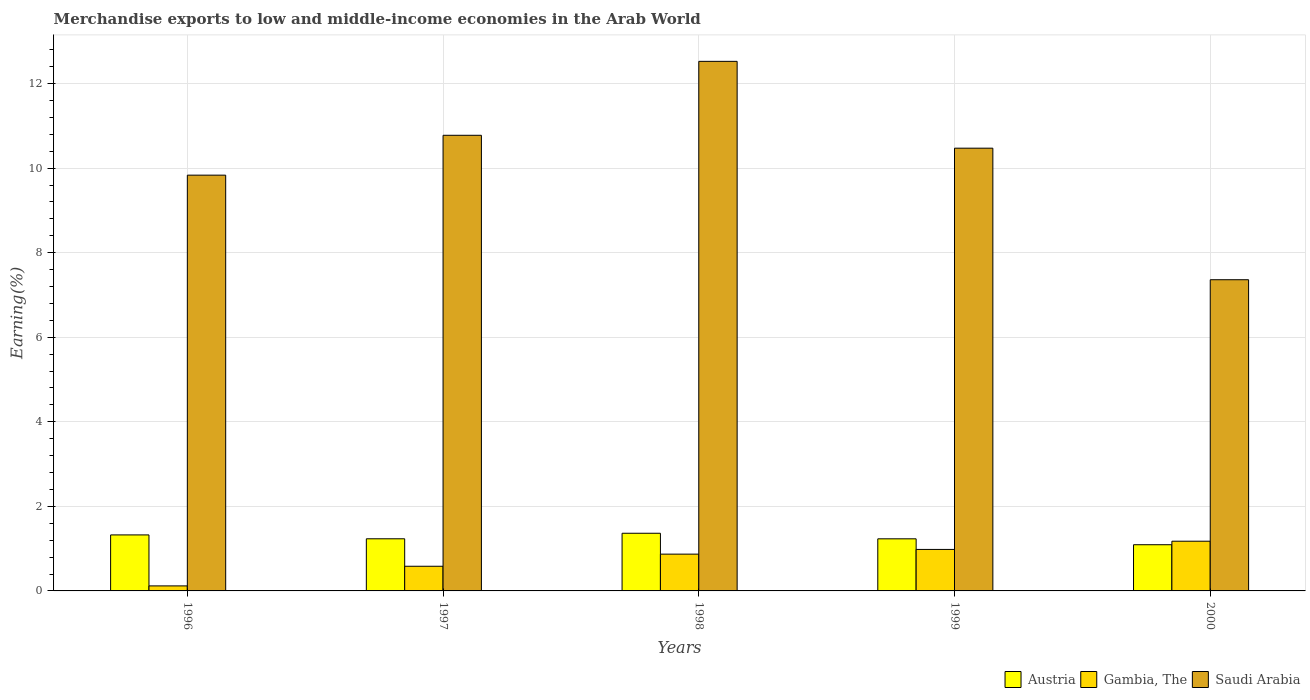How many different coloured bars are there?
Offer a terse response. 3. Are the number of bars on each tick of the X-axis equal?
Your answer should be compact. Yes. How many bars are there on the 5th tick from the right?
Your answer should be compact. 3. What is the label of the 4th group of bars from the left?
Make the answer very short. 1999. In how many cases, is the number of bars for a given year not equal to the number of legend labels?
Make the answer very short. 0. What is the percentage of amount earned from merchandise exports in Saudi Arabia in 1997?
Your response must be concise. 10.78. Across all years, what is the maximum percentage of amount earned from merchandise exports in Austria?
Your answer should be compact. 1.36. Across all years, what is the minimum percentage of amount earned from merchandise exports in Gambia, The?
Your answer should be compact. 0.12. What is the total percentage of amount earned from merchandise exports in Austria in the graph?
Your answer should be very brief. 6.25. What is the difference between the percentage of amount earned from merchandise exports in Austria in 1997 and that in 1998?
Make the answer very short. -0.13. What is the difference between the percentage of amount earned from merchandise exports in Gambia, The in 1997 and the percentage of amount earned from merchandise exports in Austria in 1996?
Provide a succinct answer. -0.74. What is the average percentage of amount earned from merchandise exports in Austria per year?
Keep it short and to the point. 1.25. In the year 2000, what is the difference between the percentage of amount earned from merchandise exports in Gambia, The and percentage of amount earned from merchandise exports in Saudi Arabia?
Your answer should be very brief. -6.18. In how many years, is the percentage of amount earned from merchandise exports in Austria greater than 9.2 %?
Keep it short and to the point. 0. What is the ratio of the percentage of amount earned from merchandise exports in Gambia, The in 1996 to that in 1999?
Your answer should be very brief. 0.12. Is the percentage of amount earned from merchandise exports in Austria in 1997 less than that in 2000?
Make the answer very short. No. Is the difference between the percentage of amount earned from merchandise exports in Gambia, The in 1996 and 1999 greater than the difference between the percentage of amount earned from merchandise exports in Saudi Arabia in 1996 and 1999?
Keep it short and to the point. No. What is the difference between the highest and the second highest percentage of amount earned from merchandise exports in Saudi Arabia?
Offer a terse response. 1.75. What is the difference between the highest and the lowest percentage of amount earned from merchandise exports in Gambia, The?
Make the answer very short. 1.06. What does the 3rd bar from the left in 1997 represents?
Offer a very short reply. Saudi Arabia. What does the 2nd bar from the right in 1996 represents?
Ensure brevity in your answer.  Gambia, The. Are all the bars in the graph horizontal?
Give a very brief answer. No. How many years are there in the graph?
Provide a succinct answer. 5. What is the difference between two consecutive major ticks on the Y-axis?
Ensure brevity in your answer.  2. Are the values on the major ticks of Y-axis written in scientific E-notation?
Your answer should be compact. No. Does the graph contain any zero values?
Your answer should be very brief. No. Does the graph contain grids?
Offer a very short reply. Yes. How many legend labels are there?
Your response must be concise. 3. How are the legend labels stacked?
Offer a very short reply. Horizontal. What is the title of the graph?
Ensure brevity in your answer.  Merchandise exports to low and middle-income economies in the Arab World. What is the label or title of the X-axis?
Your answer should be very brief. Years. What is the label or title of the Y-axis?
Provide a succinct answer. Earning(%). What is the Earning(%) in Austria in 1996?
Offer a terse response. 1.32. What is the Earning(%) of Gambia, The in 1996?
Provide a short and direct response. 0.12. What is the Earning(%) in Saudi Arabia in 1996?
Your answer should be compact. 9.83. What is the Earning(%) of Austria in 1997?
Ensure brevity in your answer.  1.23. What is the Earning(%) of Gambia, The in 1997?
Offer a very short reply. 0.58. What is the Earning(%) of Saudi Arabia in 1997?
Offer a terse response. 10.78. What is the Earning(%) of Austria in 1998?
Ensure brevity in your answer.  1.36. What is the Earning(%) in Gambia, The in 1998?
Make the answer very short. 0.87. What is the Earning(%) in Saudi Arabia in 1998?
Your response must be concise. 12.53. What is the Earning(%) of Austria in 1999?
Provide a succinct answer. 1.23. What is the Earning(%) of Gambia, The in 1999?
Offer a very short reply. 0.98. What is the Earning(%) in Saudi Arabia in 1999?
Give a very brief answer. 10.47. What is the Earning(%) in Austria in 2000?
Offer a very short reply. 1.09. What is the Earning(%) of Gambia, The in 2000?
Your answer should be very brief. 1.18. What is the Earning(%) of Saudi Arabia in 2000?
Ensure brevity in your answer.  7.36. Across all years, what is the maximum Earning(%) in Austria?
Give a very brief answer. 1.36. Across all years, what is the maximum Earning(%) of Gambia, The?
Make the answer very short. 1.18. Across all years, what is the maximum Earning(%) of Saudi Arabia?
Offer a very short reply. 12.53. Across all years, what is the minimum Earning(%) in Austria?
Provide a succinct answer. 1.09. Across all years, what is the minimum Earning(%) in Gambia, The?
Provide a short and direct response. 0.12. Across all years, what is the minimum Earning(%) in Saudi Arabia?
Make the answer very short. 7.36. What is the total Earning(%) in Austria in the graph?
Provide a short and direct response. 6.25. What is the total Earning(%) of Gambia, The in the graph?
Your answer should be very brief. 3.73. What is the total Earning(%) in Saudi Arabia in the graph?
Make the answer very short. 50.97. What is the difference between the Earning(%) of Austria in 1996 and that in 1997?
Give a very brief answer. 0.09. What is the difference between the Earning(%) of Gambia, The in 1996 and that in 1997?
Offer a very short reply. -0.46. What is the difference between the Earning(%) in Saudi Arabia in 1996 and that in 1997?
Keep it short and to the point. -0.94. What is the difference between the Earning(%) in Austria in 1996 and that in 1998?
Offer a very short reply. -0.04. What is the difference between the Earning(%) of Gambia, The in 1996 and that in 1998?
Keep it short and to the point. -0.75. What is the difference between the Earning(%) of Saudi Arabia in 1996 and that in 1998?
Provide a succinct answer. -2.69. What is the difference between the Earning(%) of Austria in 1996 and that in 1999?
Provide a short and direct response. 0.09. What is the difference between the Earning(%) in Gambia, The in 1996 and that in 1999?
Provide a short and direct response. -0.86. What is the difference between the Earning(%) of Saudi Arabia in 1996 and that in 1999?
Your answer should be very brief. -0.64. What is the difference between the Earning(%) in Austria in 1996 and that in 2000?
Provide a succinct answer. 0.23. What is the difference between the Earning(%) of Gambia, The in 1996 and that in 2000?
Your answer should be very brief. -1.06. What is the difference between the Earning(%) of Saudi Arabia in 1996 and that in 2000?
Keep it short and to the point. 2.47. What is the difference between the Earning(%) in Austria in 1997 and that in 1998?
Your answer should be compact. -0.13. What is the difference between the Earning(%) in Gambia, The in 1997 and that in 1998?
Your response must be concise. -0.29. What is the difference between the Earning(%) of Saudi Arabia in 1997 and that in 1998?
Provide a short and direct response. -1.75. What is the difference between the Earning(%) of Austria in 1997 and that in 1999?
Offer a very short reply. 0. What is the difference between the Earning(%) of Gambia, The in 1997 and that in 1999?
Your answer should be very brief. -0.4. What is the difference between the Earning(%) in Saudi Arabia in 1997 and that in 1999?
Ensure brevity in your answer.  0.3. What is the difference between the Earning(%) in Austria in 1997 and that in 2000?
Your answer should be very brief. 0.14. What is the difference between the Earning(%) in Gambia, The in 1997 and that in 2000?
Offer a terse response. -0.59. What is the difference between the Earning(%) in Saudi Arabia in 1997 and that in 2000?
Provide a short and direct response. 3.42. What is the difference between the Earning(%) in Austria in 1998 and that in 1999?
Your answer should be compact. 0.13. What is the difference between the Earning(%) in Gambia, The in 1998 and that in 1999?
Provide a succinct answer. -0.11. What is the difference between the Earning(%) in Saudi Arabia in 1998 and that in 1999?
Provide a succinct answer. 2.05. What is the difference between the Earning(%) in Austria in 1998 and that in 2000?
Keep it short and to the point. 0.27. What is the difference between the Earning(%) in Gambia, The in 1998 and that in 2000?
Ensure brevity in your answer.  -0.31. What is the difference between the Earning(%) of Saudi Arabia in 1998 and that in 2000?
Your answer should be very brief. 5.17. What is the difference between the Earning(%) of Austria in 1999 and that in 2000?
Your response must be concise. 0.14. What is the difference between the Earning(%) of Gambia, The in 1999 and that in 2000?
Keep it short and to the point. -0.19. What is the difference between the Earning(%) in Saudi Arabia in 1999 and that in 2000?
Your answer should be compact. 3.11. What is the difference between the Earning(%) of Austria in 1996 and the Earning(%) of Gambia, The in 1997?
Your response must be concise. 0.74. What is the difference between the Earning(%) of Austria in 1996 and the Earning(%) of Saudi Arabia in 1997?
Provide a succinct answer. -9.45. What is the difference between the Earning(%) in Gambia, The in 1996 and the Earning(%) in Saudi Arabia in 1997?
Ensure brevity in your answer.  -10.66. What is the difference between the Earning(%) in Austria in 1996 and the Earning(%) in Gambia, The in 1998?
Provide a succinct answer. 0.45. What is the difference between the Earning(%) in Austria in 1996 and the Earning(%) in Saudi Arabia in 1998?
Ensure brevity in your answer.  -11.2. What is the difference between the Earning(%) in Gambia, The in 1996 and the Earning(%) in Saudi Arabia in 1998?
Your answer should be very brief. -12.41. What is the difference between the Earning(%) in Austria in 1996 and the Earning(%) in Gambia, The in 1999?
Offer a terse response. 0.34. What is the difference between the Earning(%) of Austria in 1996 and the Earning(%) of Saudi Arabia in 1999?
Your response must be concise. -9.15. What is the difference between the Earning(%) in Gambia, The in 1996 and the Earning(%) in Saudi Arabia in 1999?
Make the answer very short. -10.35. What is the difference between the Earning(%) in Austria in 1996 and the Earning(%) in Gambia, The in 2000?
Give a very brief answer. 0.15. What is the difference between the Earning(%) in Austria in 1996 and the Earning(%) in Saudi Arabia in 2000?
Provide a short and direct response. -6.04. What is the difference between the Earning(%) of Gambia, The in 1996 and the Earning(%) of Saudi Arabia in 2000?
Your response must be concise. -7.24. What is the difference between the Earning(%) in Austria in 1997 and the Earning(%) in Gambia, The in 1998?
Keep it short and to the point. 0.36. What is the difference between the Earning(%) in Austria in 1997 and the Earning(%) in Saudi Arabia in 1998?
Provide a succinct answer. -11.29. What is the difference between the Earning(%) in Gambia, The in 1997 and the Earning(%) in Saudi Arabia in 1998?
Keep it short and to the point. -11.94. What is the difference between the Earning(%) of Austria in 1997 and the Earning(%) of Gambia, The in 1999?
Offer a very short reply. 0.25. What is the difference between the Earning(%) of Austria in 1997 and the Earning(%) of Saudi Arabia in 1999?
Your response must be concise. -9.24. What is the difference between the Earning(%) of Gambia, The in 1997 and the Earning(%) of Saudi Arabia in 1999?
Keep it short and to the point. -9.89. What is the difference between the Earning(%) of Austria in 1997 and the Earning(%) of Gambia, The in 2000?
Offer a terse response. 0.06. What is the difference between the Earning(%) in Austria in 1997 and the Earning(%) in Saudi Arabia in 2000?
Offer a very short reply. -6.13. What is the difference between the Earning(%) of Gambia, The in 1997 and the Earning(%) of Saudi Arabia in 2000?
Your response must be concise. -6.78. What is the difference between the Earning(%) of Austria in 1998 and the Earning(%) of Gambia, The in 1999?
Give a very brief answer. 0.38. What is the difference between the Earning(%) in Austria in 1998 and the Earning(%) in Saudi Arabia in 1999?
Offer a terse response. -9.11. What is the difference between the Earning(%) of Gambia, The in 1998 and the Earning(%) of Saudi Arabia in 1999?
Offer a very short reply. -9.6. What is the difference between the Earning(%) in Austria in 1998 and the Earning(%) in Gambia, The in 2000?
Offer a terse response. 0.19. What is the difference between the Earning(%) of Austria in 1998 and the Earning(%) of Saudi Arabia in 2000?
Keep it short and to the point. -6. What is the difference between the Earning(%) in Gambia, The in 1998 and the Earning(%) in Saudi Arabia in 2000?
Offer a very short reply. -6.49. What is the difference between the Earning(%) of Austria in 1999 and the Earning(%) of Gambia, The in 2000?
Ensure brevity in your answer.  0.06. What is the difference between the Earning(%) of Austria in 1999 and the Earning(%) of Saudi Arabia in 2000?
Your answer should be very brief. -6.13. What is the difference between the Earning(%) in Gambia, The in 1999 and the Earning(%) in Saudi Arabia in 2000?
Your response must be concise. -6.38. What is the average Earning(%) of Austria per year?
Offer a terse response. 1.25. What is the average Earning(%) of Gambia, The per year?
Ensure brevity in your answer.  0.75. What is the average Earning(%) of Saudi Arabia per year?
Give a very brief answer. 10.19. In the year 1996, what is the difference between the Earning(%) of Austria and Earning(%) of Gambia, The?
Offer a very short reply. 1.21. In the year 1996, what is the difference between the Earning(%) in Austria and Earning(%) in Saudi Arabia?
Make the answer very short. -8.51. In the year 1996, what is the difference between the Earning(%) of Gambia, The and Earning(%) of Saudi Arabia?
Provide a succinct answer. -9.72. In the year 1997, what is the difference between the Earning(%) in Austria and Earning(%) in Gambia, The?
Keep it short and to the point. 0.65. In the year 1997, what is the difference between the Earning(%) of Austria and Earning(%) of Saudi Arabia?
Offer a very short reply. -9.54. In the year 1997, what is the difference between the Earning(%) of Gambia, The and Earning(%) of Saudi Arabia?
Offer a terse response. -10.19. In the year 1998, what is the difference between the Earning(%) of Austria and Earning(%) of Gambia, The?
Your answer should be very brief. 0.49. In the year 1998, what is the difference between the Earning(%) in Austria and Earning(%) in Saudi Arabia?
Provide a short and direct response. -11.16. In the year 1998, what is the difference between the Earning(%) of Gambia, The and Earning(%) of Saudi Arabia?
Your response must be concise. -11.66. In the year 1999, what is the difference between the Earning(%) of Austria and Earning(%) of Gambia, The?
Keep it short and to the point. 0.25. In the year 1999, what is the difference between the Earning(%) of Austria and Earning(%) of Saudi Arabia?
Make the answer very short. -9.24. In the year 1999, what is the difference between the Earning(%) of Gambia, The and Earning(%) of Saudi Arabia?
Provide a succinct answer. -9.49. In the year 2000, what is the difference between the Earning(%) in Austria and Earning(%) in Gambia, The?
Give a very brief answer. -0.08. In the year 2000, what is the difference between the Earning(%) in Austria and Earning(%) in Saudi Arabia?
Provide a succinct answer. -6.27. In the year 2000, what is the difference between the Earning(%) of Gambia, The and Earning(%) of Saudi Arabia?
Provide a short and direct response. -6.18. What is the ratio of the Earning(%) in Austria in 1996 to that in 1997?
Give a very brief answer. 1.07. What is the ratio of the Earning(%) in Gambia, The in 1996 to that in 1997?
Your answer should be very brief. 0.2. What is the ratio of the Earning(%) of Saudi Arabia in 1996 to that in 1997?
Offer a terse response. 0.91. What is the ratio of the Earning(%) in Austria in 1996 to that in 1998?
Keep it short and to the point. 0.97. What is the ratio of the Earning(%) in Gambia, The in 1996 to that in 1998?
Ensure brevity in your answer.  0.14. What is the ratio of the Earning(%) in Saudi Arabia in 1996 to that in 1998?
Offer a terse response. 0.79. What is the ratio of the Earning(%) of Austria in 1996 to that in 1999?
Your answer should be compact. 1.07. What is the ratio of the Earning(%) of Gambia, The in 1996 to that in 1999?
Provide a short and direct response. 0.12. What is the ratio of the Earning(%) of Saudi Arabia in 1996 to that in 1999?
Ensure brevity in your answer.  0.94. What is the ratio of the Earning(%) of Austria in 1996 to that in 2000?
Offer a terse response. 1.21. What is the ratio of the Earning(%) in Gambia, The in 1996 to that in 2000?
Offer a terse response. 0.1. What is the ratio of the Earning(%) in Saudi Arabia in 1996 to that in 2000?
Offer a terse response. 1.34. What is the ratio of the Earning(%) of Austria in 1997 to that in 1998?
Offer a very short reply. 0.9. What is the ratio of the Earning(%) in Gambia, The in 1997 to that in 1998?
Make the answer very short. 0.67. What is the ratio of the Earning(%) of Saudi Arabia in 1997 to that in 1998?
Make the answer very short. 0.86. What is the ratio of the Earning(%) in Austria in 1997 to that in 1999?
Offer a terse response. 1. What is the ratio of the Earning(%) in Gambia, The in 1997 to that in 1999?
Make the answer very short. 0.59. What is the ratio of the Earning(%) of Saudi Arabia in 1997 to that in 1999?
Offer a very short reply. 1.03. What is the ratio of the Earning(%) in Austria in 1997 to that in 2000?
Keep it short and to the point. 1.13. What is the ratio of the Earning(%) in Gambia, The in 1997 to that in 2000?
Offer a terse response. 0.5. What is the ratio of the Earning(%) of Saudi Arabia in 1997 to that in 2000?
Your response must be concise. 1.46. What is the ratio of the Earning(%) in Austria in 1998 to that in 1999?
Your answer should be compact. 1.11. What is the ratio of the Earning(%) in Gambia, The in 1998 to that in 1999?
Your answer should be very brief. 0.89. What is the ratio of the Earning(%) in Saudi Arabia in 1998 to that in 1999?
Offer a terse response. 1.2. What is the ratio of the Earning(%) of Austria in 1998 to that in 2000?
Make the answer very short. 1.25. What is the ratio of the Earning(%) of Gambia, The in 1998 to that in 2000?
Offer a very short reply. 0.74. What is the ratio of the Earning(%) in Saudi Arabia in 1998 to that in 2000?
Provide a short and direct response. 1.7. What is the ratio of the Earning(%) in Austria in 1999 to that in 2000?
Make the answer very short. 1.13. What is the ratio of the Earning(%) in Gambia, The in 1999 to that in 2000?
Keep it short and to the point. 0.83. What is the ratio of the Earning(%) in Saudi Arabia in 1999 to that in 2000?
Make the answer very short. 1.42. What is the difference between the highest and the second highest Earning(%) of Austria?
Give a very brief answer. 0.04. What is the difference between the highest and the second highest Earning(%) of Gambia, The?
Keep it short and to the point. 0.19. What is the difference between the highest and the second highest Earning(%) in Saudi Arabia?
Make the answer very short. 1.75. What is the difference between the highest and the lowest Earning(%) in Austria?
Give a very brief answer. 0.27. What is the difference between the highest and the lowest Earning(%) of Gambia, The?
Make the answer very short. 1.06. What is the difference between the highest and the lowest Earning(%) of Saudi Arabia?
Ensure brevity in your answer.  5.17. 